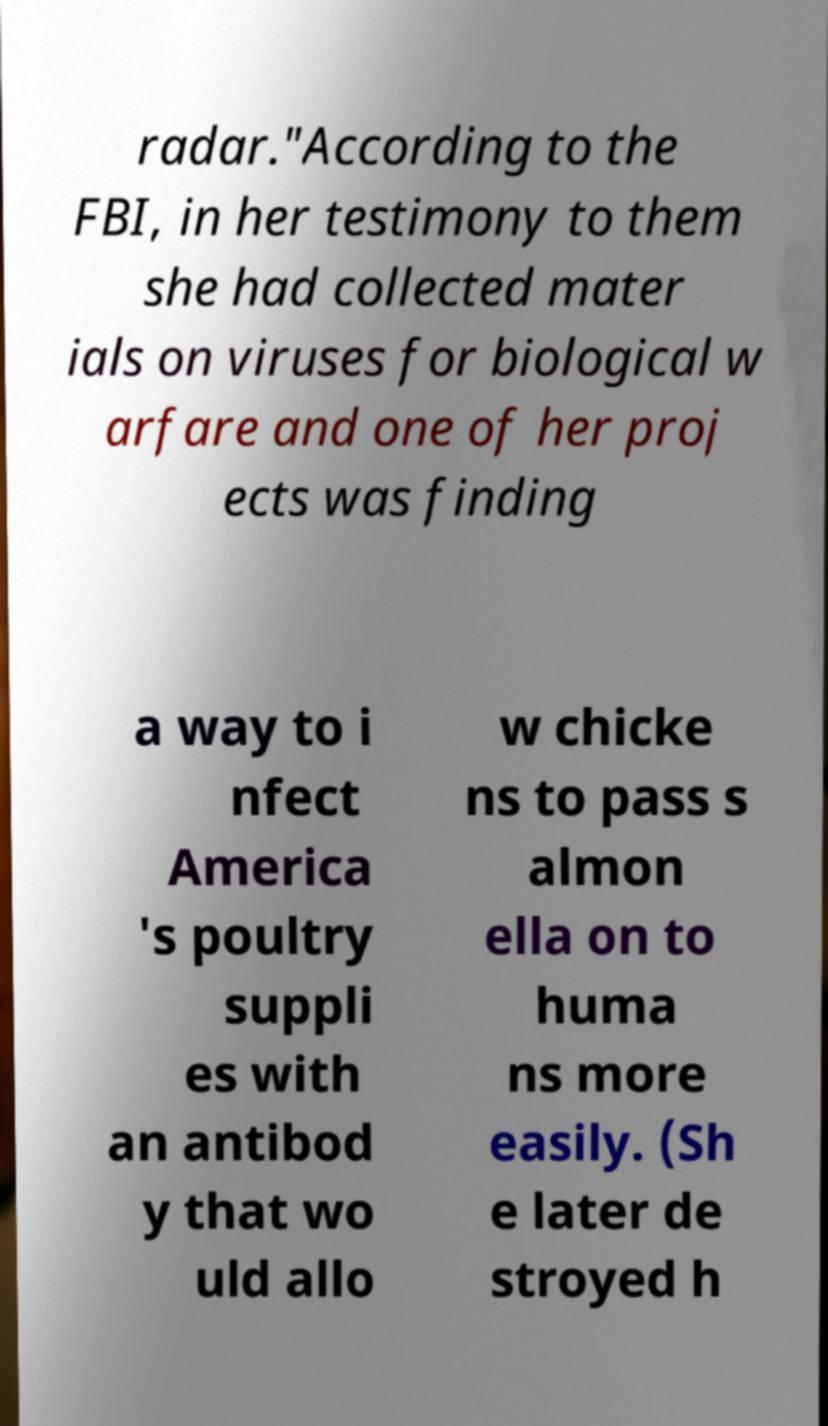Please read and relay the text visible in this image. What does it say? radar."According to the FBI, in her testimony to them she had collected mater ials on viruses for biological w arfare and one of her proj ects was finding a way to i nfect America 's poultry suppli es with an antibod y that wo uld allo w chicke ns to pass s almon ella on to huma ns more easily. (Sh e later de stroyed h 